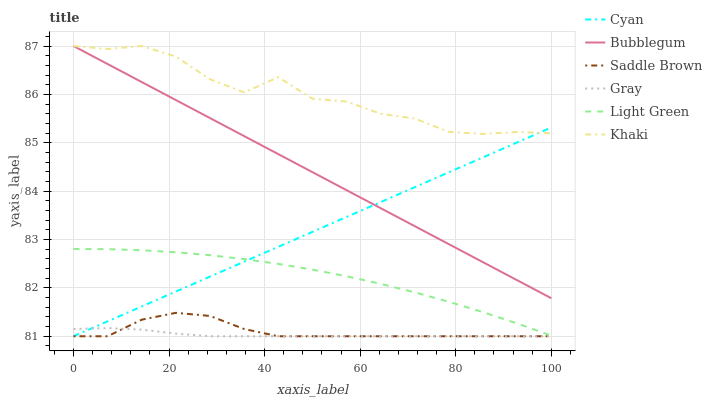Does Bubblegum have the minimum area under the curve?
Answer yes or no. No. Does Bubblegum have the maximum area under the curve?
Answer yes or no. No. Is Bubblegum the smoothest?
Answer yes or no. No. Is Bubblegum the roughest?
Answer yes or no. No. Does Bubblegum have the lowest value?
Answer yes or no. No. Does Light Green have the highest value?
Answer yes or no. No. Is Light Green less than Bubblegum?
Answer yes or no. Yes. Is Light Green greater than Gray?
Answer yes or no. Yes. Does Light Green intersect Bubblegum?
Answer yes or no. No. 